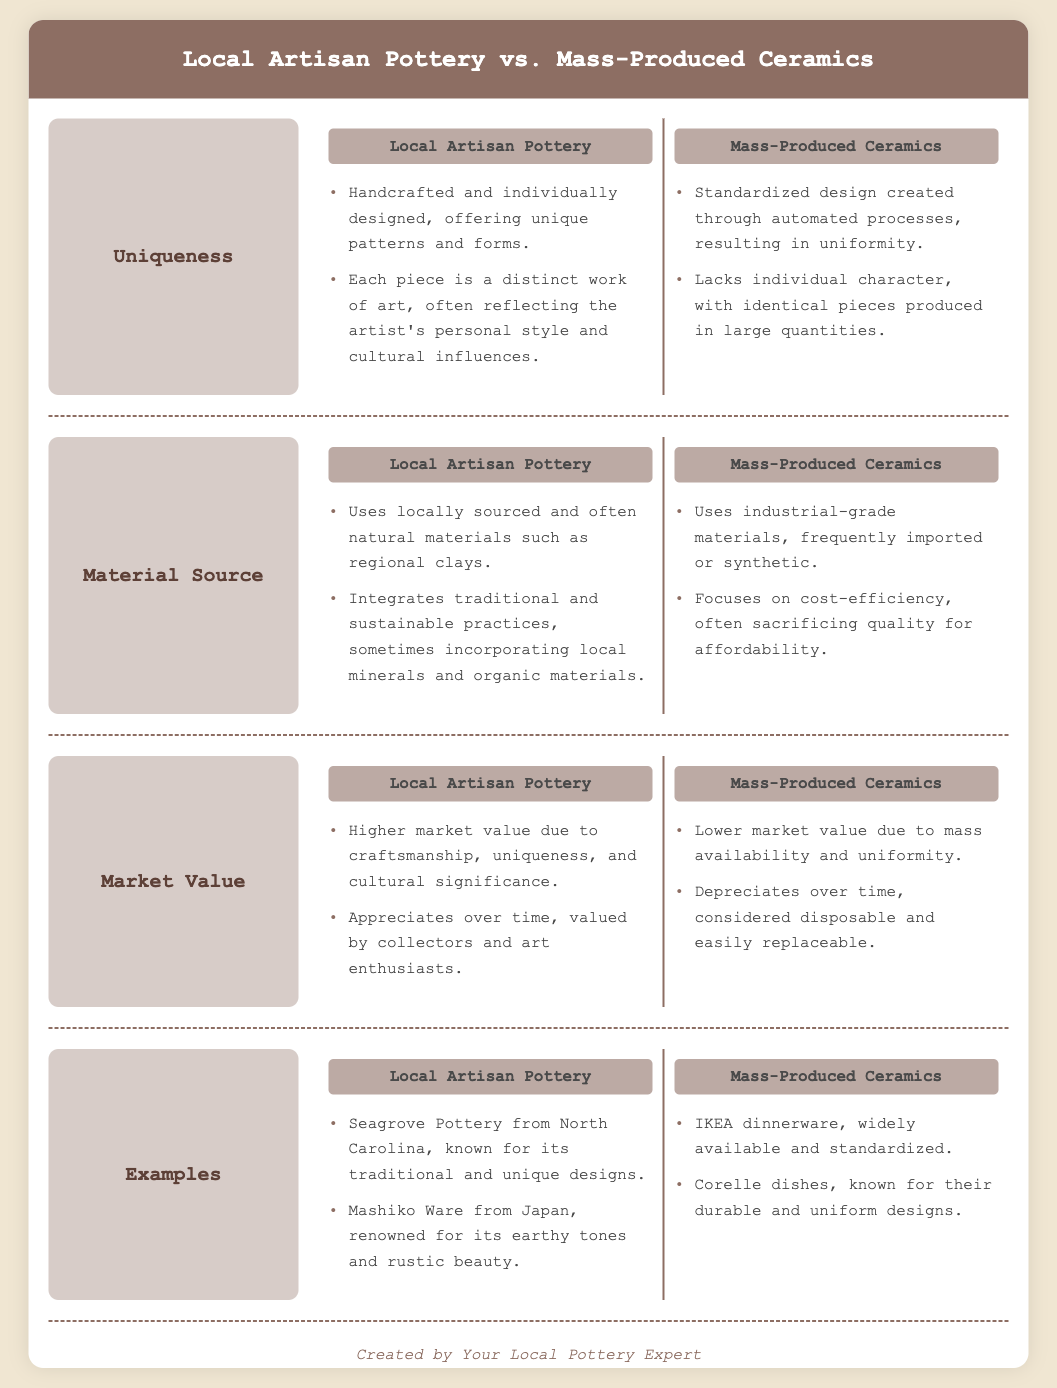What is the main focus of the comparison infographic? The infographic compares local artisan pottery and mass-produced ceramics in terms of uniqueness, material source, and market value.
Answer: Local Artisan Pottery vs. Mass-Produced Ceramics What is a characteristic of local artisan pottery? The document states that local artisan pottery is handcrafted and offers unique patterns and forms.
Answer: Handcrafted and individually designed What materials do local artisans use for pottery? According to the document, local artisan pottery uses locally sourced and often natural materials such as regional clays.
Answer: Locally sourced and often natural materials How does the market value of local artisan pottery compare to mass-produced ceramics? The document indicates that local artisan pottery has a higher market value due to its craftsmanship and uniqueness.
Answer: Higher market value What is an example of mass-produced ceramics given in the document? The document provides examples of mass-produced ceramics, including IKEA dinnerware and Corelle dishes.
Answer: IKEA dinnerware In what way does mass-produced ceramics sacrifice quality? It sacrifices quality for affordability by using industrial-grade materials.
Answer: Sacrifices quality for affordability What happens to the value of local artisan pottery over time? The document mentions that local artisan pottery appreciates over time and is valued by collectors.
Answer: Appreciates over time Why would someone prefer local artisan pottery over mass-produced ceramics? The document highlights uniqueness, craftsmanship, and cultural significance as reasons for preference.
Answer: Uniqueness, craftsmanship, and cultural significance How does material sourcing differ between local artisan and mass-produced ceramics? Local artisans focus on traditional and sustainable practices, while mass-produced ceramics use industrial-grade materials.
Answer: Traditional and sustainable practices vs. industrial-grade materials 